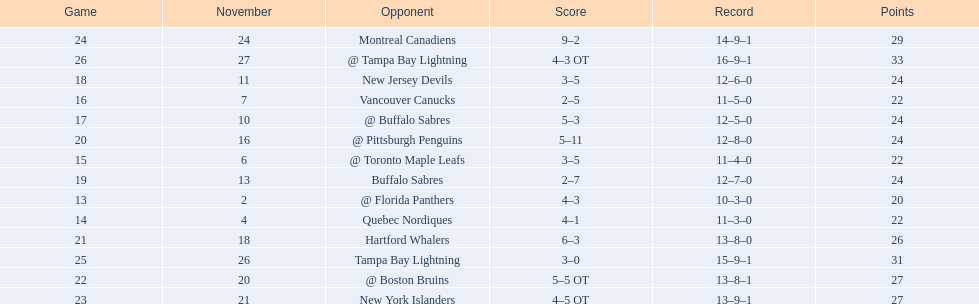Which teams scored 35 points or more in total? Hartford Whalers, @ Boston Bruins, New York Islanders, Montreal Canadiens, Tampa Bay Lightning, @ Tampa Bay Lightning. Of those teams, which team was the only one to score 3-0? Tampa Bay Lightning. 